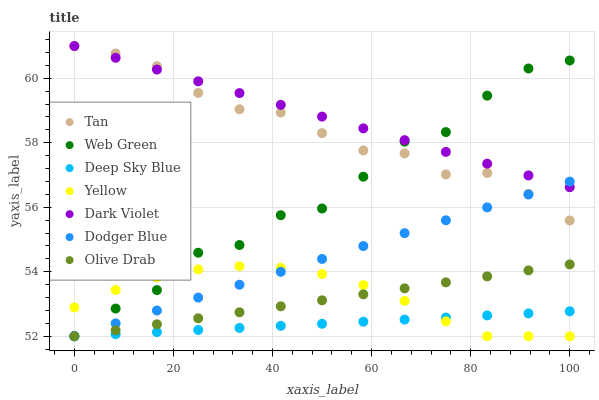Does Deep Sky Blue have the minimum area under the curve?
Answer yes or no. Yes. Does Dark Violet have the maximum area under the curve?
Answer yes or no. Yes. Does Dodger Blue have the minimum area under the curve?
Answer yes or no. No. Does Dodger Blue have the maximum area under the curve?
Answer yes or no. No. Is Olive Drab the smoothest?
Answer yes or no. Yes. Is Web Green the roughest?
Answer yes or no. Yes. Is Dark Violet the smoothest?
Answer yes or no. No. Is Dark Violet the roughest?
Answer yes or no. No. Does Web Green have the lowest value?
Answer yes or no. Yes. Does Dark Violet have the lowest value?
Answer yes or no. No. Does Tan have the highest value?
Answer yes or no. Yes. Does Dodger Blue have the highest value?
Answer yes or no. No. Is Yellow less than Dark Violet?
Answer yes or no. Yes. Is Tan greater than Deep Sky Blue?
Answer yes or no. Yes. Does Yellow intersect Olive Drab?
Answer yes or no. Yes. Is Yellow less than Olive Drab?
Answer yes or no. No. Is Yellow greater than Olive Drab?
Answer yes or no. No. Does Yellow intersect Dark Violet?
Answer yes or no. No. 